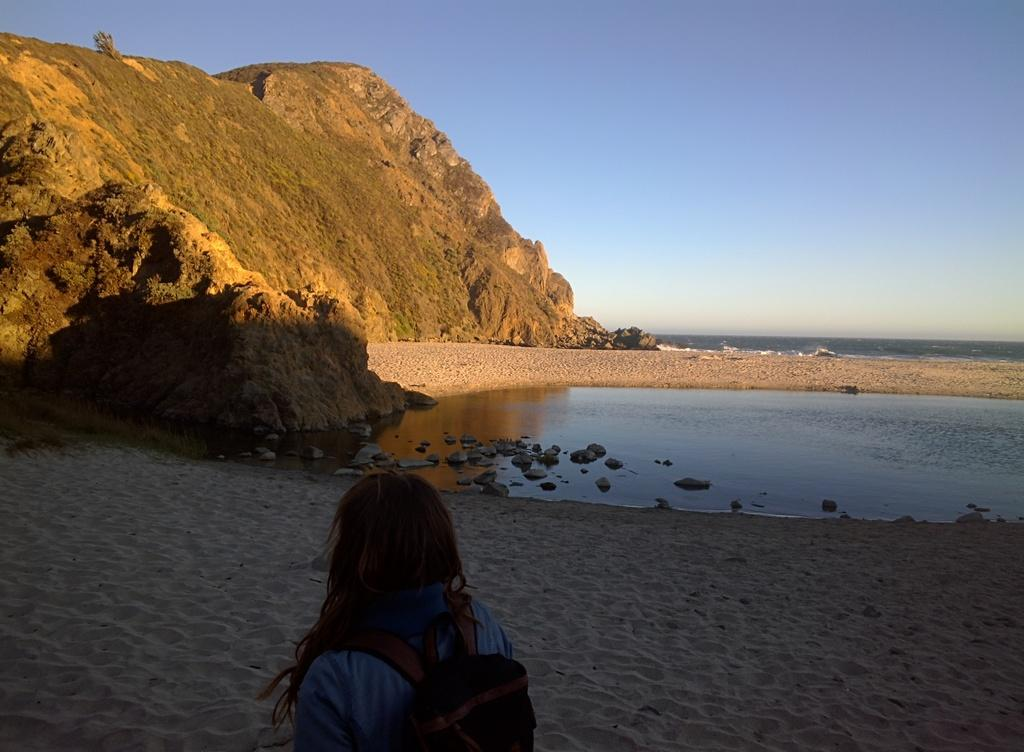Who is present in the image? There is a person in the image. What is the person carrying? The person is carrying a bag. What can be seen on the water in the image? There are stones on the water in the image. What type of terrain is visible in the image? There is sand visible in the image. What can be seen in the distance in the image? There is a mountain in the background of the image, and the sky is also visible. How many family members are present in the image? There is no indication of family members in the image; only one person is present. What is the person rubbing on their skin in the image? There is no indication of the person rubbing anything on their skin in the image. 